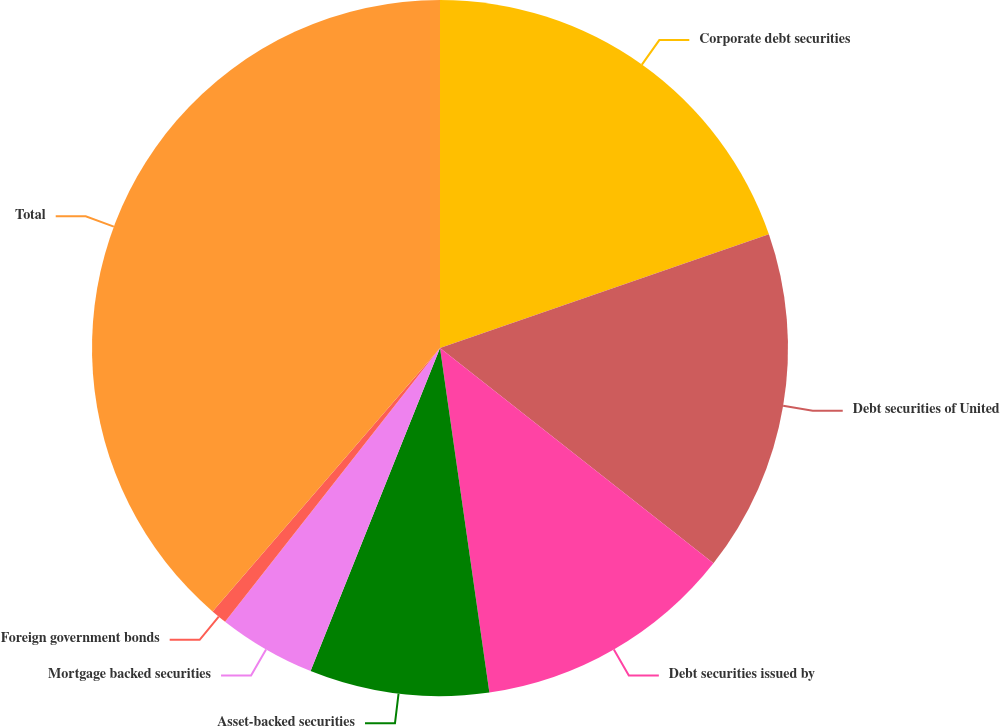<chart> <loc_0><loc_0><loc_500><loc_500><pie_chart><fcel>Corporate debt securities<fcel>Debt securities of United<fcel>Debt securities issued by<fcel>Asset-backed securities<fcel>Mortgage backed securities<fcel>Foreign government bonds<fcel>Total<nl><fcel>19.7%<fcel>15.91%<fcel>12.12%<fcel>8.33%<fcel>4.53%<fcel>0.74%<fcel>38.66%<nl></chart> 